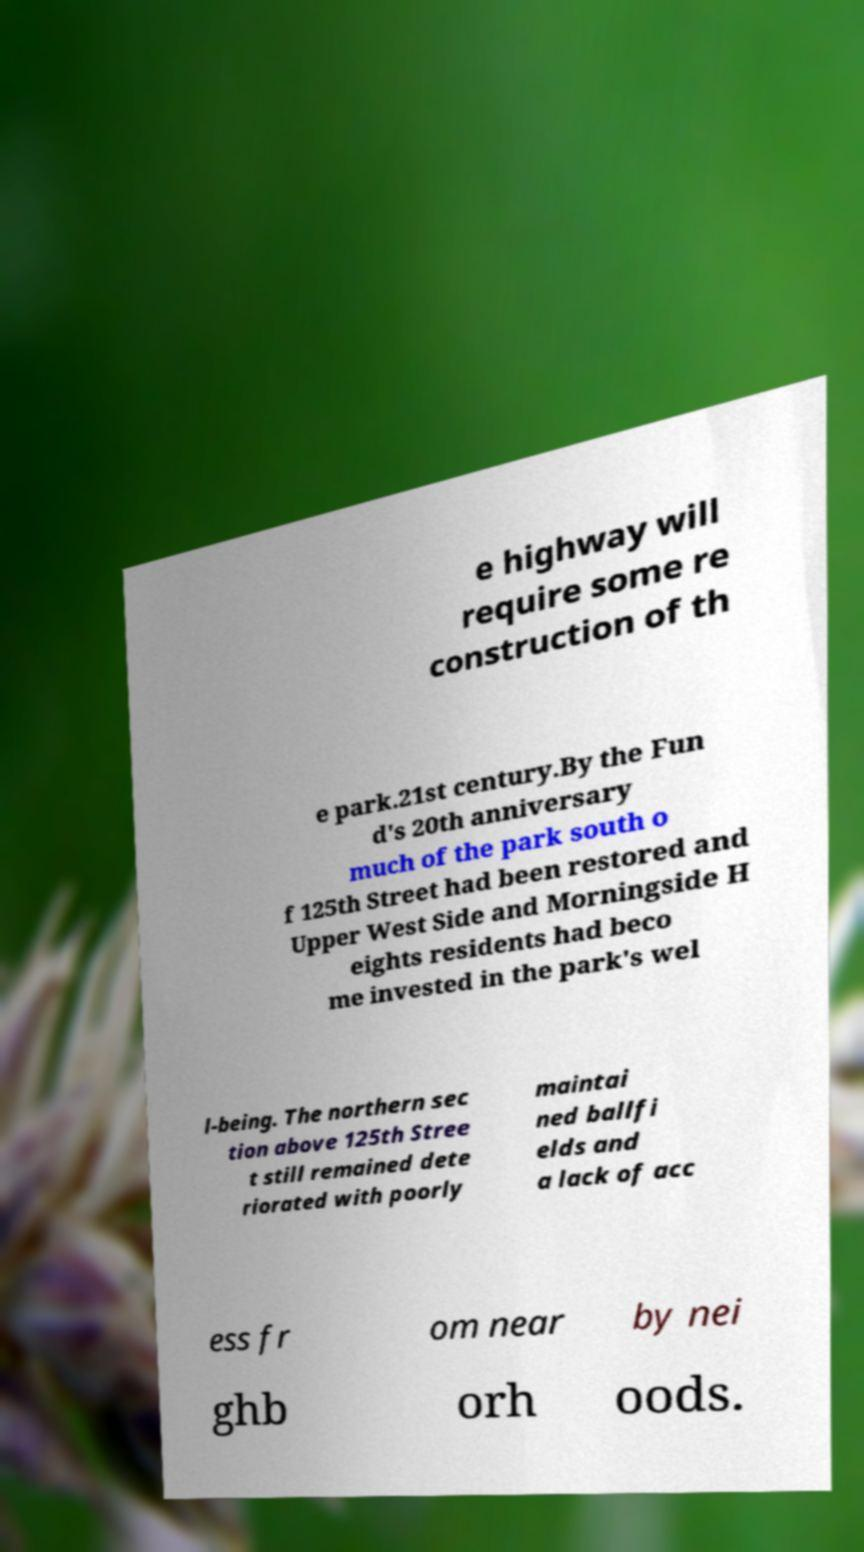Please read and relay the text visible in this image. What does it say? e highway will require some re construction of th e park.21st century.By the Fun d's 20th anniversary much of the park south o f 125th Street had been restored and Upper West Side and Morningside H eights residents had beco me invested in the park's wel l-being. The northern sec tion above 125th Stree t still remained dete riorated with poorly maintai ned ballfi elds and a lack of acc ess fr om near by nei ghb orh oods. 